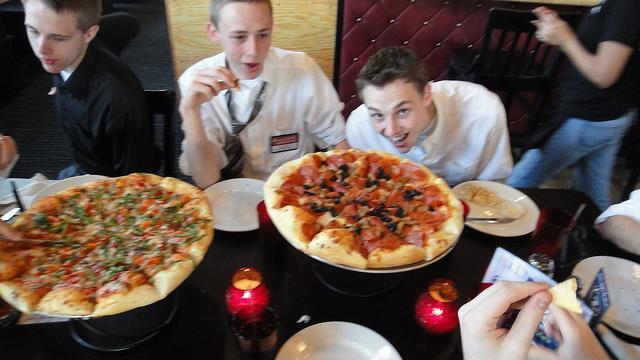How many pizzas are pictured?
Give a very brief answer. 2. How many pizzas are there?
Give a very brief answer. 2. How many people can you see?
Give a very brief answer. 6. How many chairs are there?
Give a very brief answer. 2. How many bears do you see?
Give a very brief answer. 0. 